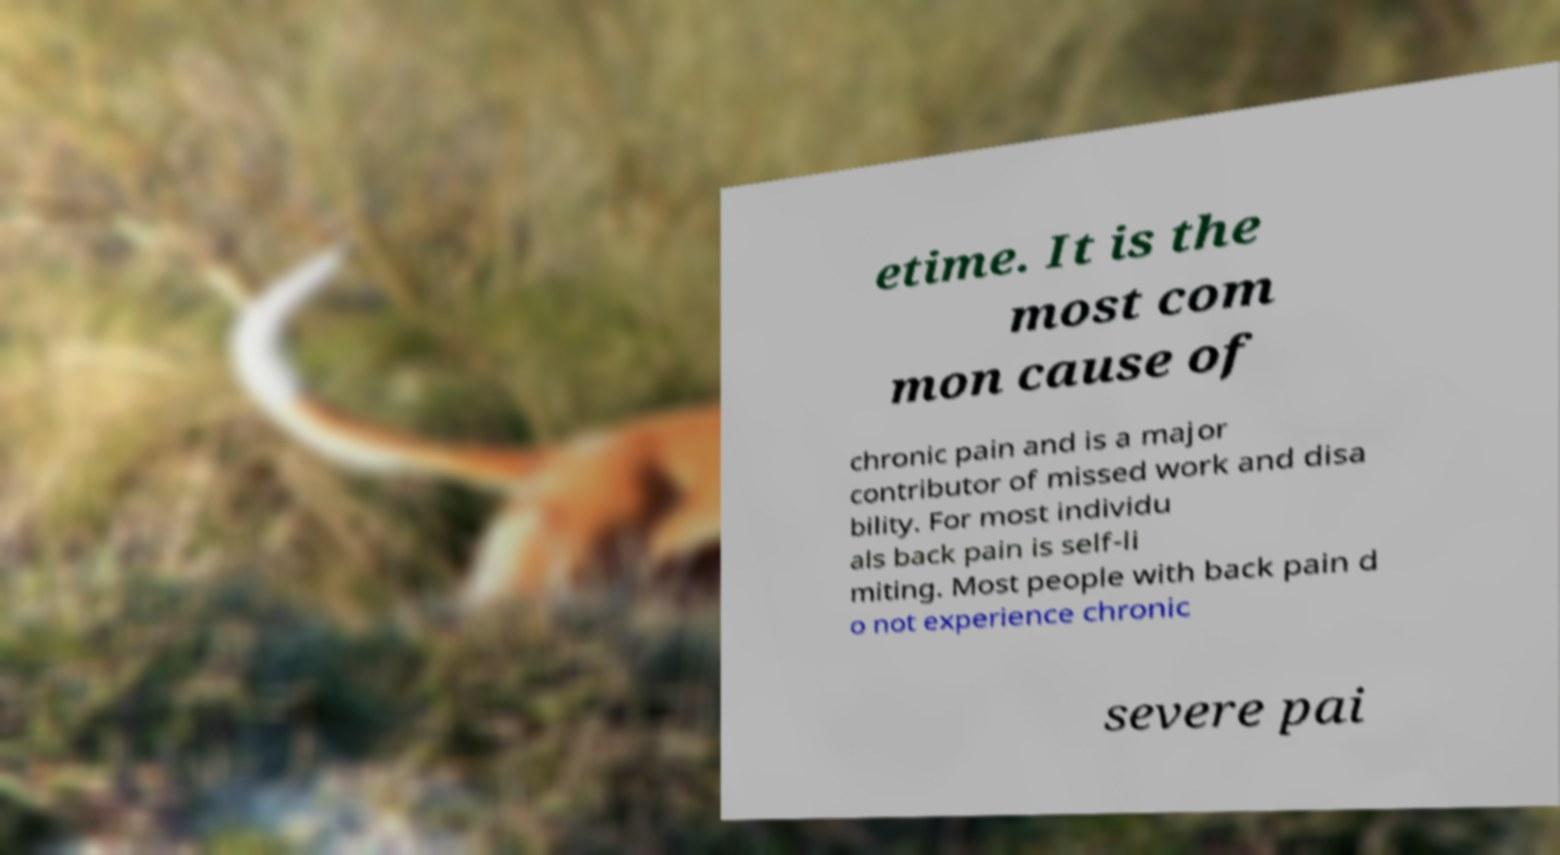I need the written content from this picture converted into text. Can you do that? etime. It is the most com mon cause of chronic pain and is a major contributor of missed work and disa bility. For most individu als back pain is self-li miting. Most people with back pain d o not experience chronic severe pai 